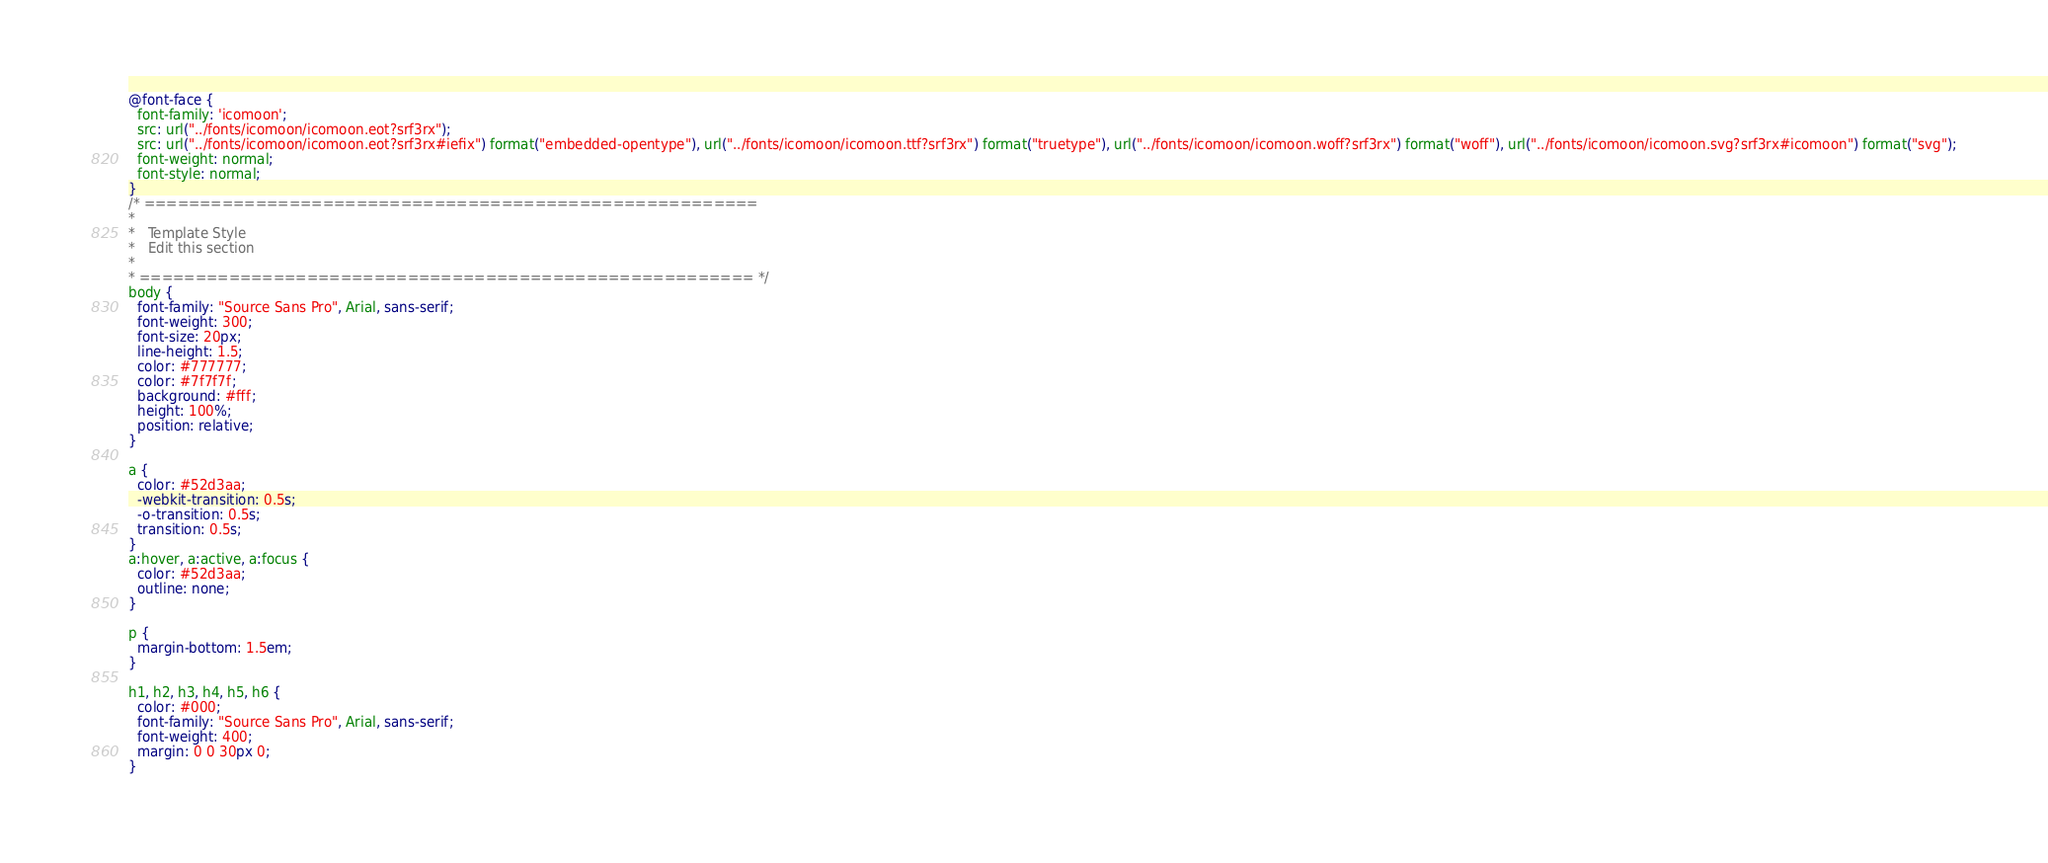<code> <loc_0><loc_0><loc_500><loc_500><_CSS_>@font-face {
  font-family: 'icomoon';
  src: url("../fonts/icomoon/icomoon.eot?srf3rx");
  src: url("../fonts/icomoon/icomoon.eot?srf3rx#iefix") format("embedded-opentype"), url("../fonts/icomoon/icomoon.ttf?srf3rx") format("truetype"), url("../fonts/icomoon/icomoon.woff?srf3rx") format("woff"), url("../fonts/icomoon/icomoon.svg?srf3rx#icomoon") format("svg");
  font-weight: normal;
  font-style: normal;
}
/* =======================================================
*
* 	Template Style 
*	Edit this section
*
* ======================================================= */
body {
  font-family: "Source Sans Pro", Arial, sans-serif;
  font-weight: 300;
  font-size: 20px;
  line-height: 1.5;
  color: #777777;
  color: #7f7f7f;
  background: #fff;
  height: 100%;
  position: relative;
}

a {
  color: #52d3aa;
  -webkit-transition: 0.5s;
  -o-transition: 0.5s;
  transition: 0.5s;
}
a:hover, a:active, a:focus {
  color: #52d3aa;
  outline: none;
}

p {
  margin-bottom: 1.5em;
}

h1, h2, h3, h4, h5, h6 {
  color: #000;
  font-family: "Source Sans Pro", Arial, sans-serif;
  font-weight: 400;
  margin: 0 0 30px 0;
}
</code> 